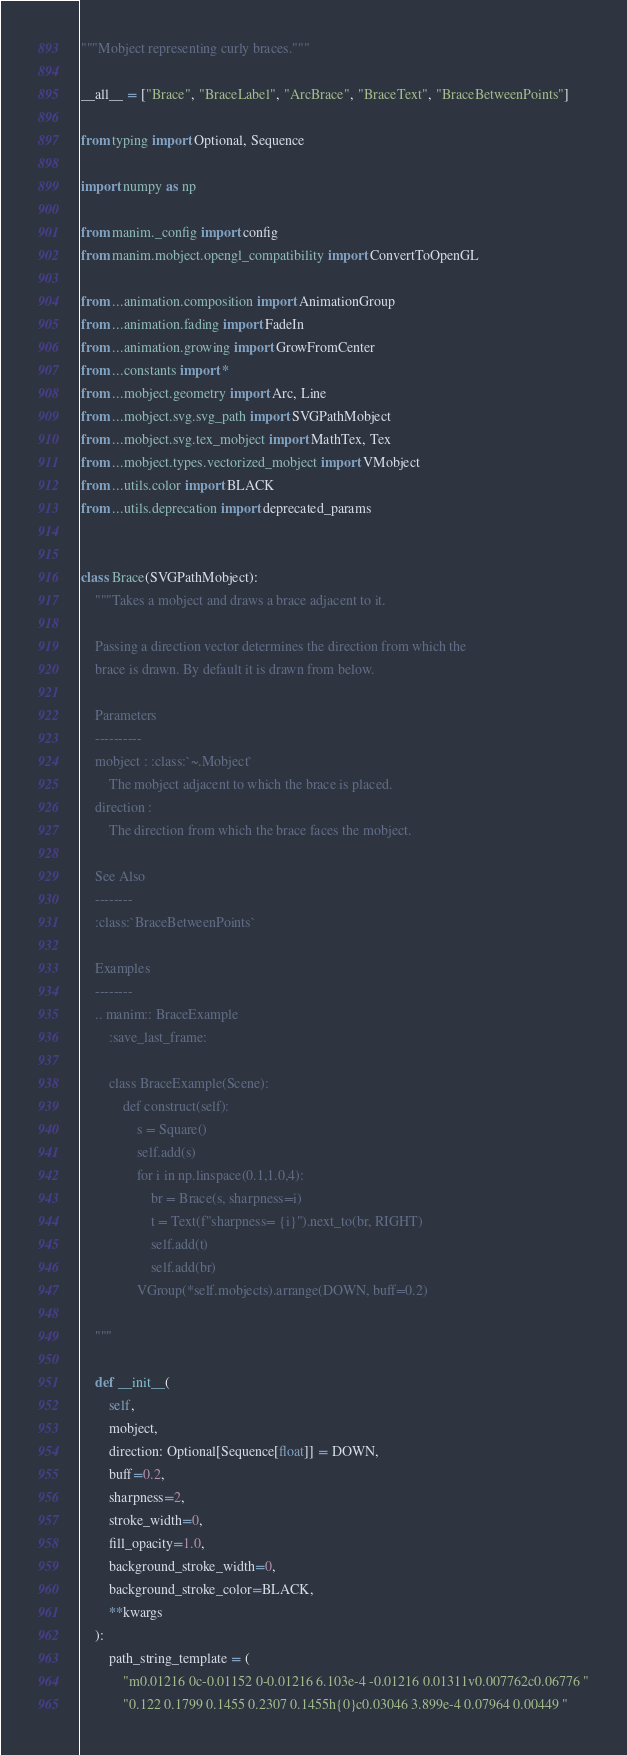Convert code to text. <code><loc_0><loc_0><loc_500><loc_500><_Python_>"""Mobject representing curly braces."""

__all__ = ["Brace", "BraceLabel", "ArcBrace", "BraceText", "BraceBetweenPoints"]

from typing import Optional, Sequence

import numpy as np

from manim._config import config
from manim.mobject.opengl_compatibility import ConvertToOpenGL

from ...animation.composition import AnimationGroup
from ...animation.fading import FadeIn
from ...animation.growing import GrowFromCenter
from ...constants import *
from ...mobject.geometry import Arc, Line
from ...mobject.svg.svg_path import SVGPathMobject
from ...mobject.svg.tex_mobject import MathTex, Tex
from ...mobject.types.vectorized_mobject import VMobject
from ...utils.color import BLACK
from ...utils.deprecation import deprecated_params


class Brace(SVGPathMobject):
    """Takes a mobject and draws a brace adjacent to it.

    Passing a direction vector determines the direction from which the
    brace is drawn. By default it is drawn from below.

    Parameters
    ----------
    mobject : :class:`~.Mobject`
        The mobject adjacent to which the brace is placed.
    direction :
        The direction from which the brace faces the mobject.

    See Also
    --------
    :class:`BraceBetweenPoints`

    Examples
    --------
    .. manim:: BraceExample
        :save_last_frame:

        class BraceExample(Scene):
            def construct(self):
                s = Square()
                self.add(s)
                for i in np.linspace(0.1,1.0,4):
                    br = Brace(s, sharpness=i)
                    t = Text(f"sharpness= {i}").next_to(br, RIGHT)
                    self.add(t)
                    self.add(br)
                VGroup(*self.mobjects).arrange(DOWN, buff=0.2)

    """

    def __init__(
        self,
        mobject,
        direction: Optional[Sequence[float]] = DOWN,
        buff=0.2,
        sharpness=2,
        stroke_width=0,
        fill_opacity=1.0,
        background_stroke_width=0,
        background_stroke_color=BLACK,
        **kwargs
    ):
        path_string_template = (
            "m0.01216 0c-0.01152 0-0.01216 6.103e-4 -0.01216 0.01311v0.007762c0.06776 "
            "0.122 0.1799 0.1455 0.2307 0.1455h{0}c0.03046 3.899e-4 0.07964 0.00449 "</code> 